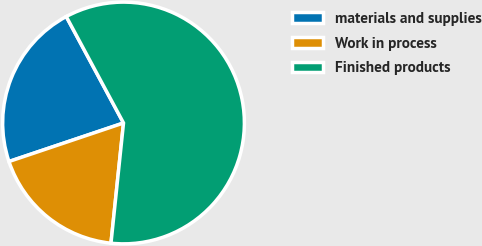Convert chart to OTSL. <chart><loc_0><loc_0><loc_500><loc_500><pie_chart><fcel>materials and supplies<fcel>Work in process<fcel>Finished products<nl><fcel>22.31%<fcel>18.18%<fcel>59.51%<nl></chart> 